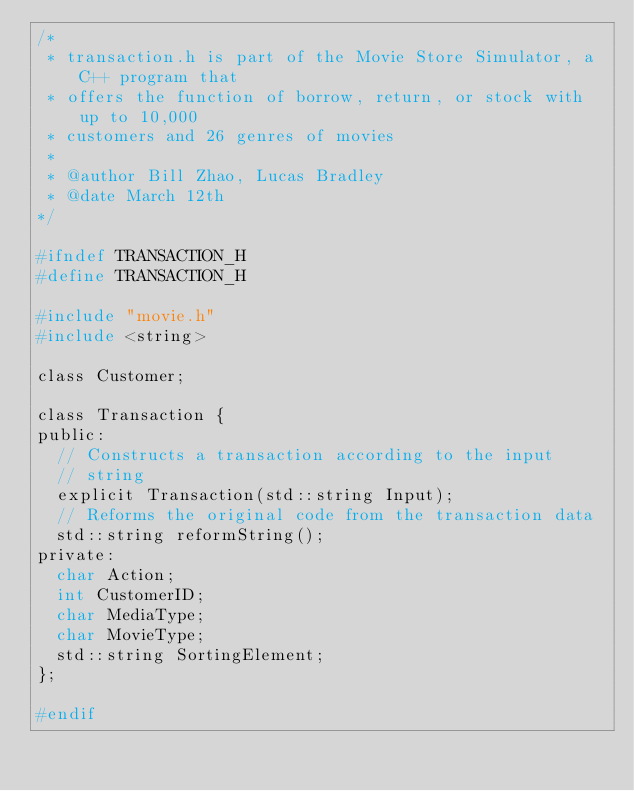<code> <loc_0><loc_0><loc_500><loc_500><_C_>/*
 * transaction.h is part of the Movie Store Simulator, a C++ program that
 * offers the function of borrow, return, or stock with up to 10,000
 * customers and 26 genres of movies
 *
 * @author Bill Zhao, Lucas Bradley
 * @date March 12th
*/

#ifndef TRANSACTION_H
#define TRANSACTION_H

#include "movie.h"
#include <string>

class Customer;

class Transaction {
public:
  // Constructs a transaction according to the input
  // string
  explicit Transaction(std::string Input);
  // Reforms the original code from the transaction data
  std::string reformString();
private:
  char Action;
  int CustomerID;
  char MediaType;
  char MovieType;
  std::string SortingElement;
};

#endif</code> 